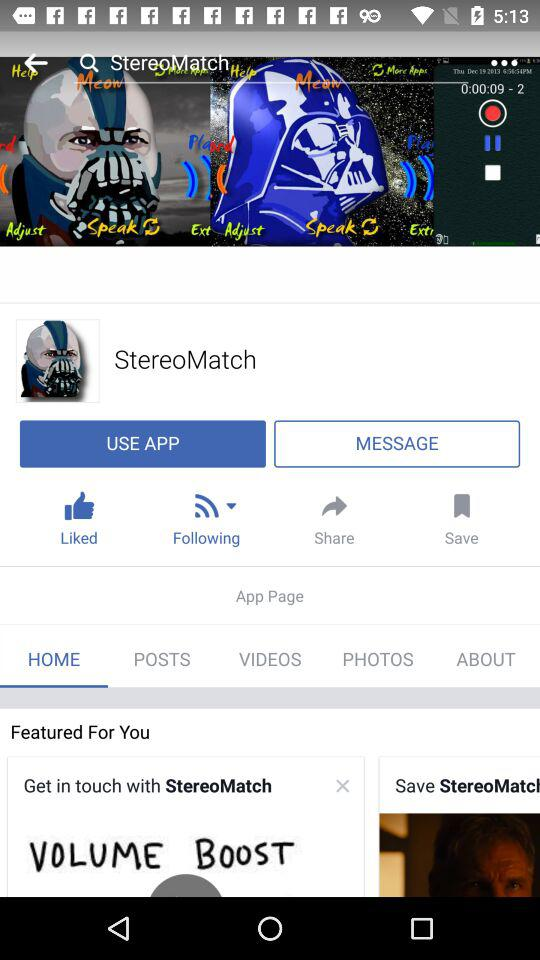What is the account name? The account name is "StereoMatch". 